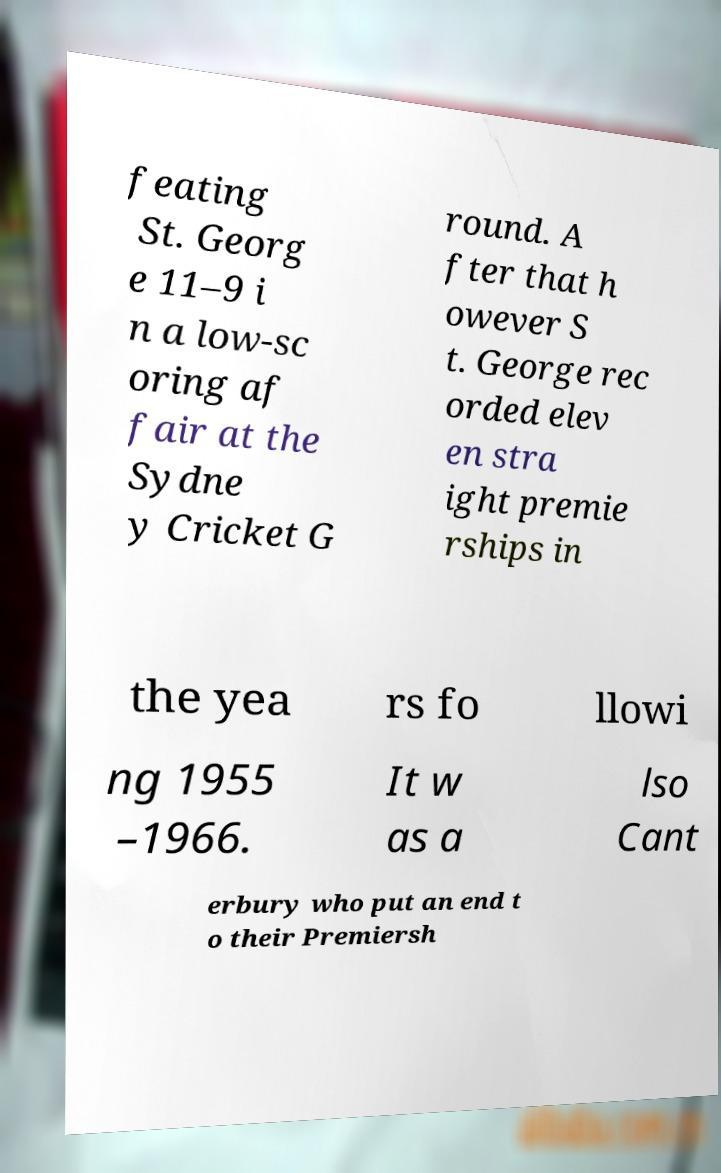For documentation purposes, I need the text within this image transcribed. Could you provide that? feating St. Georg e 11–9 i n a low-sc oring af fair at the Sydne y Cricket G round. A fter that h owever S t. George rec orded elev en stra ight premie rships in the yea rs fo llowi ng 1955 –1966. It w as a lso Cant erbury who put an end t o their Premiersh 